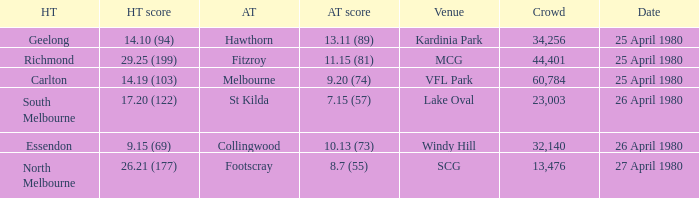On what date did the match at Lake Oval take place? 26 April 1980. 